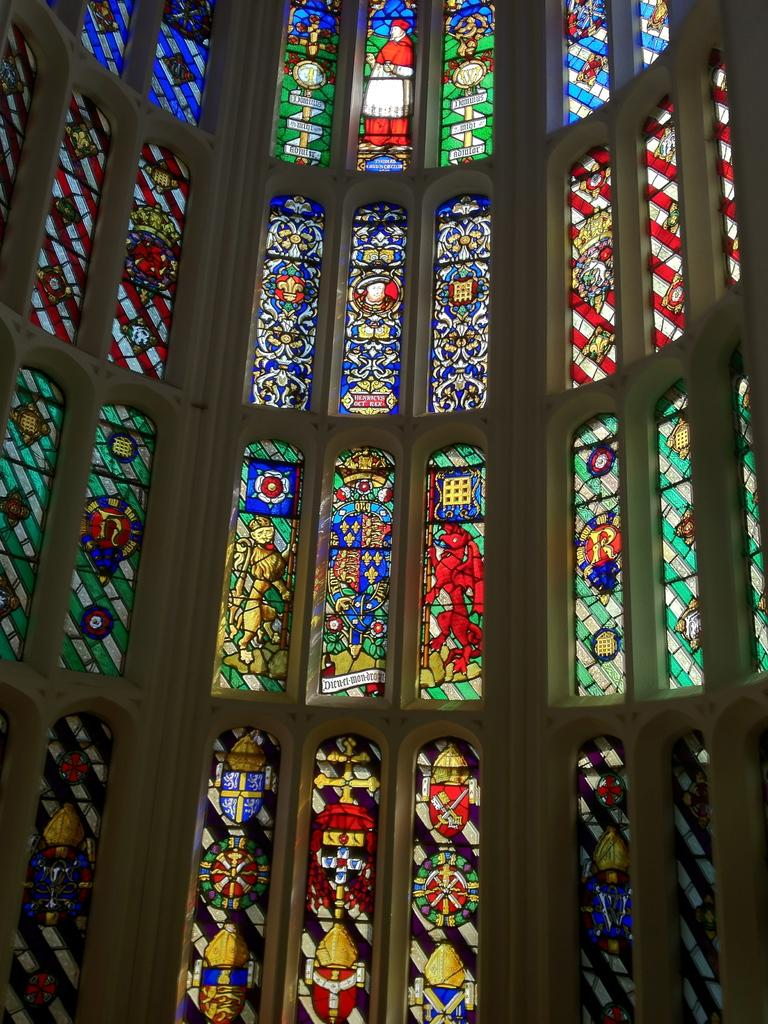Where was the image most likely taken? The image was likely taken indoors. What can be seen on the wall in the image? There is a wall of a building in the image, and it has printed and colorful glasses. How many people are crying in the image? There are no people visible in the image, so it is not possible to determine if anyone is crying. 